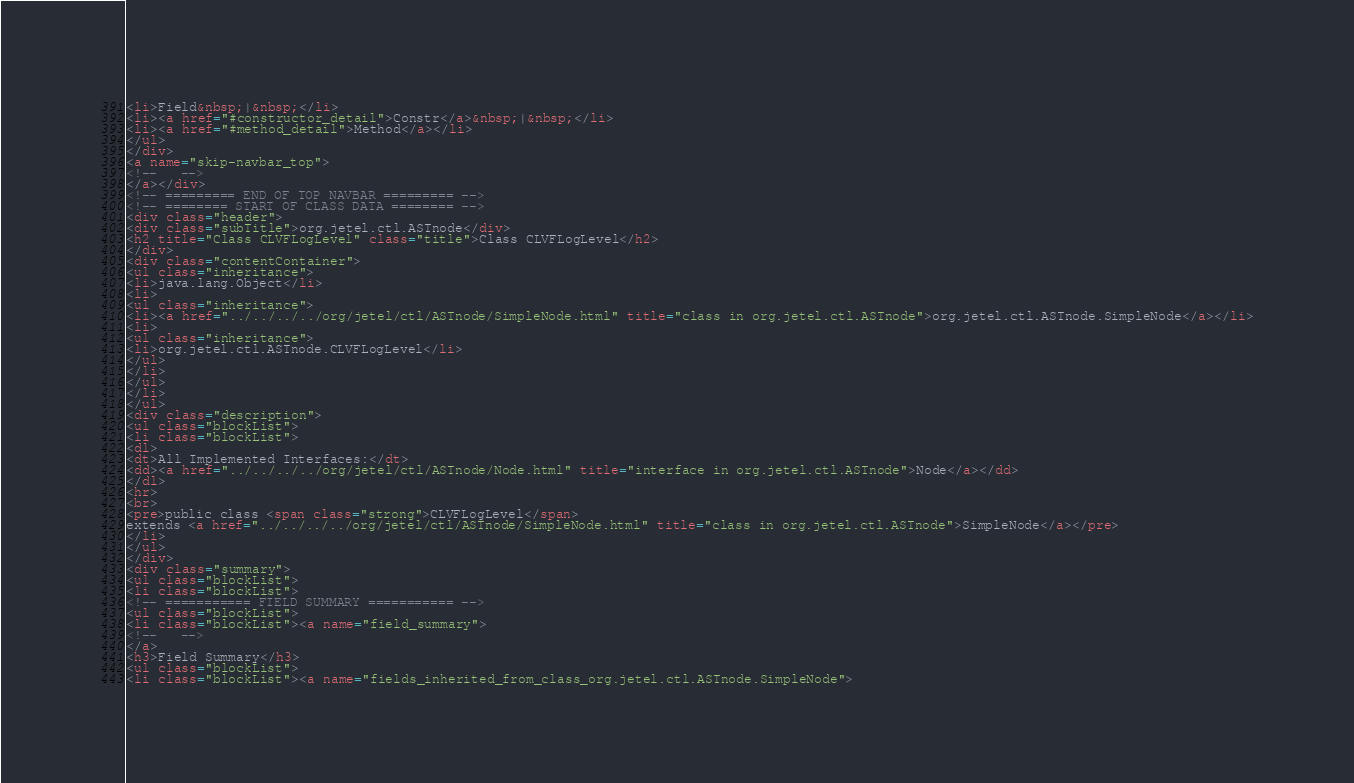Convert code to text. <code><loc_0><loc_0><loc_500><loc_500><_HTML_><li>Field&nbsp;|&nbsp;</li>
<li><a href="#constructor_detail">Constr</a>&nbsp;|&nbsp;</li>
<li><a href="#method_detail">Method</a></li>
</ul>
</div>
<a name="skip-navbar_top">
<!--   -->
</a></div>
<!-- ========= END OF TOP NAVBAR ========= -->
<!-- ======== START OF CLASS DATA ======== -->
<div class="header">
<div class="subTitle">org.jetel.ctl.ASTnode</div>
<h2 title="Class CLVFLogLevel" class="title">Class CLVFLogLevel</h2>
</div>
<div class="contentContainer">
<ul class="inheritance">
<li>java.lang.Object</li>
<li>
<ul class="inheritance">
<li><a href="../../../../org/jetel/ctl/ASTnode/SimpleNode.html" title="class in org.jetel.ctl.ASTnode">org.jetel.ctl.ASTnode.SimpleNode</a></li>
<li>
<ul class="inheritance">
<li>org.jetel.ctl.ASTnode.CLVFLogLevel</li>
</ul>
</li>
</ul>
</li>
</ul>
<div class="description">
<ul class="blockList">
<li class="blockList">
<dl>
<dt>All Implemented Interfaces:</dt>
<dd><a href="../../../../org/jetel/ctl/ASTnode/Node.html" title="interface in org.jetel.ctl.ASTnode">Node</a></dd>
</dl>
<hr>
<br>
<pre>public class <span class="strong">CLVFLogLevel</span>
extends <a href="../../../../org/jetel/ctl/ASTnode/SimpleNode.html" title="class in org.jetel.ctl.ASTnode">SimpleNode</a></pre>
</li>
</ul>
</div>
<div class="summary">
<ul class="blockList">
<li class="blockList">
<!-- =========== FIELD SUMMARY =========== -->
<ul class="blockList">
<li class="blockList"><a name="field_summary">
<!--   -->
</a>
<h3>Field Summary</h3>
<ul class="blockList">
<li class="blockList"><a name="fields_inherited_from_class_org.jetel.ctl.ASTnode.SimpleNode"></code> 